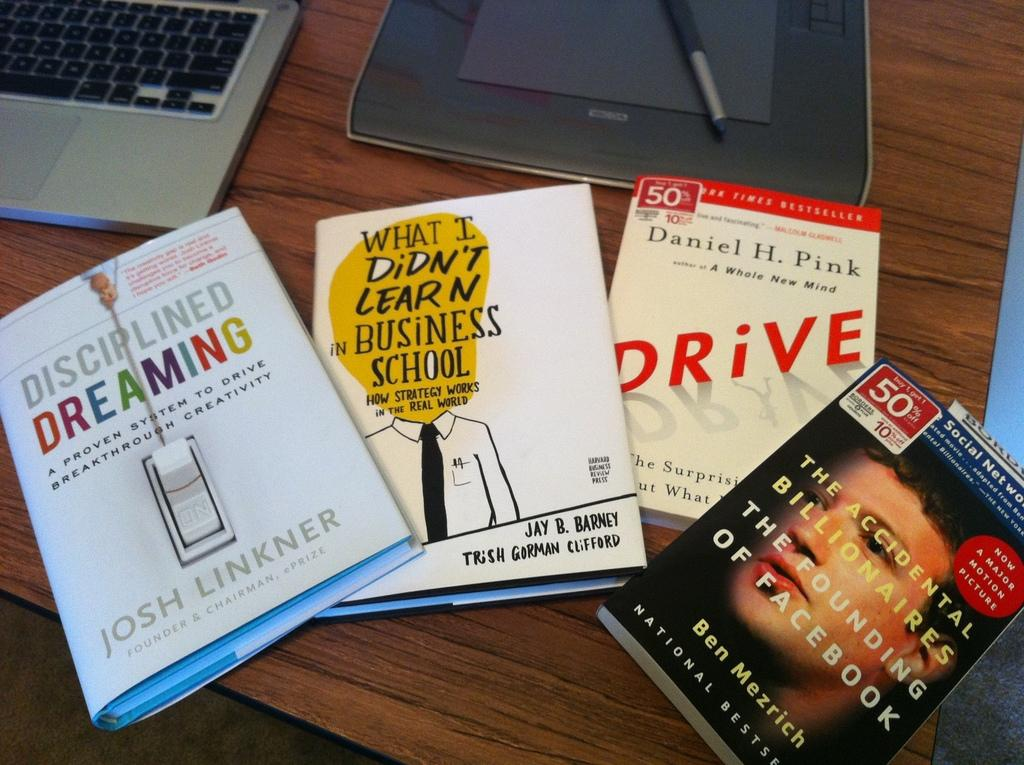Provide a one-sentence caption for the provided image. One of the several books on the table is titled Drive. 